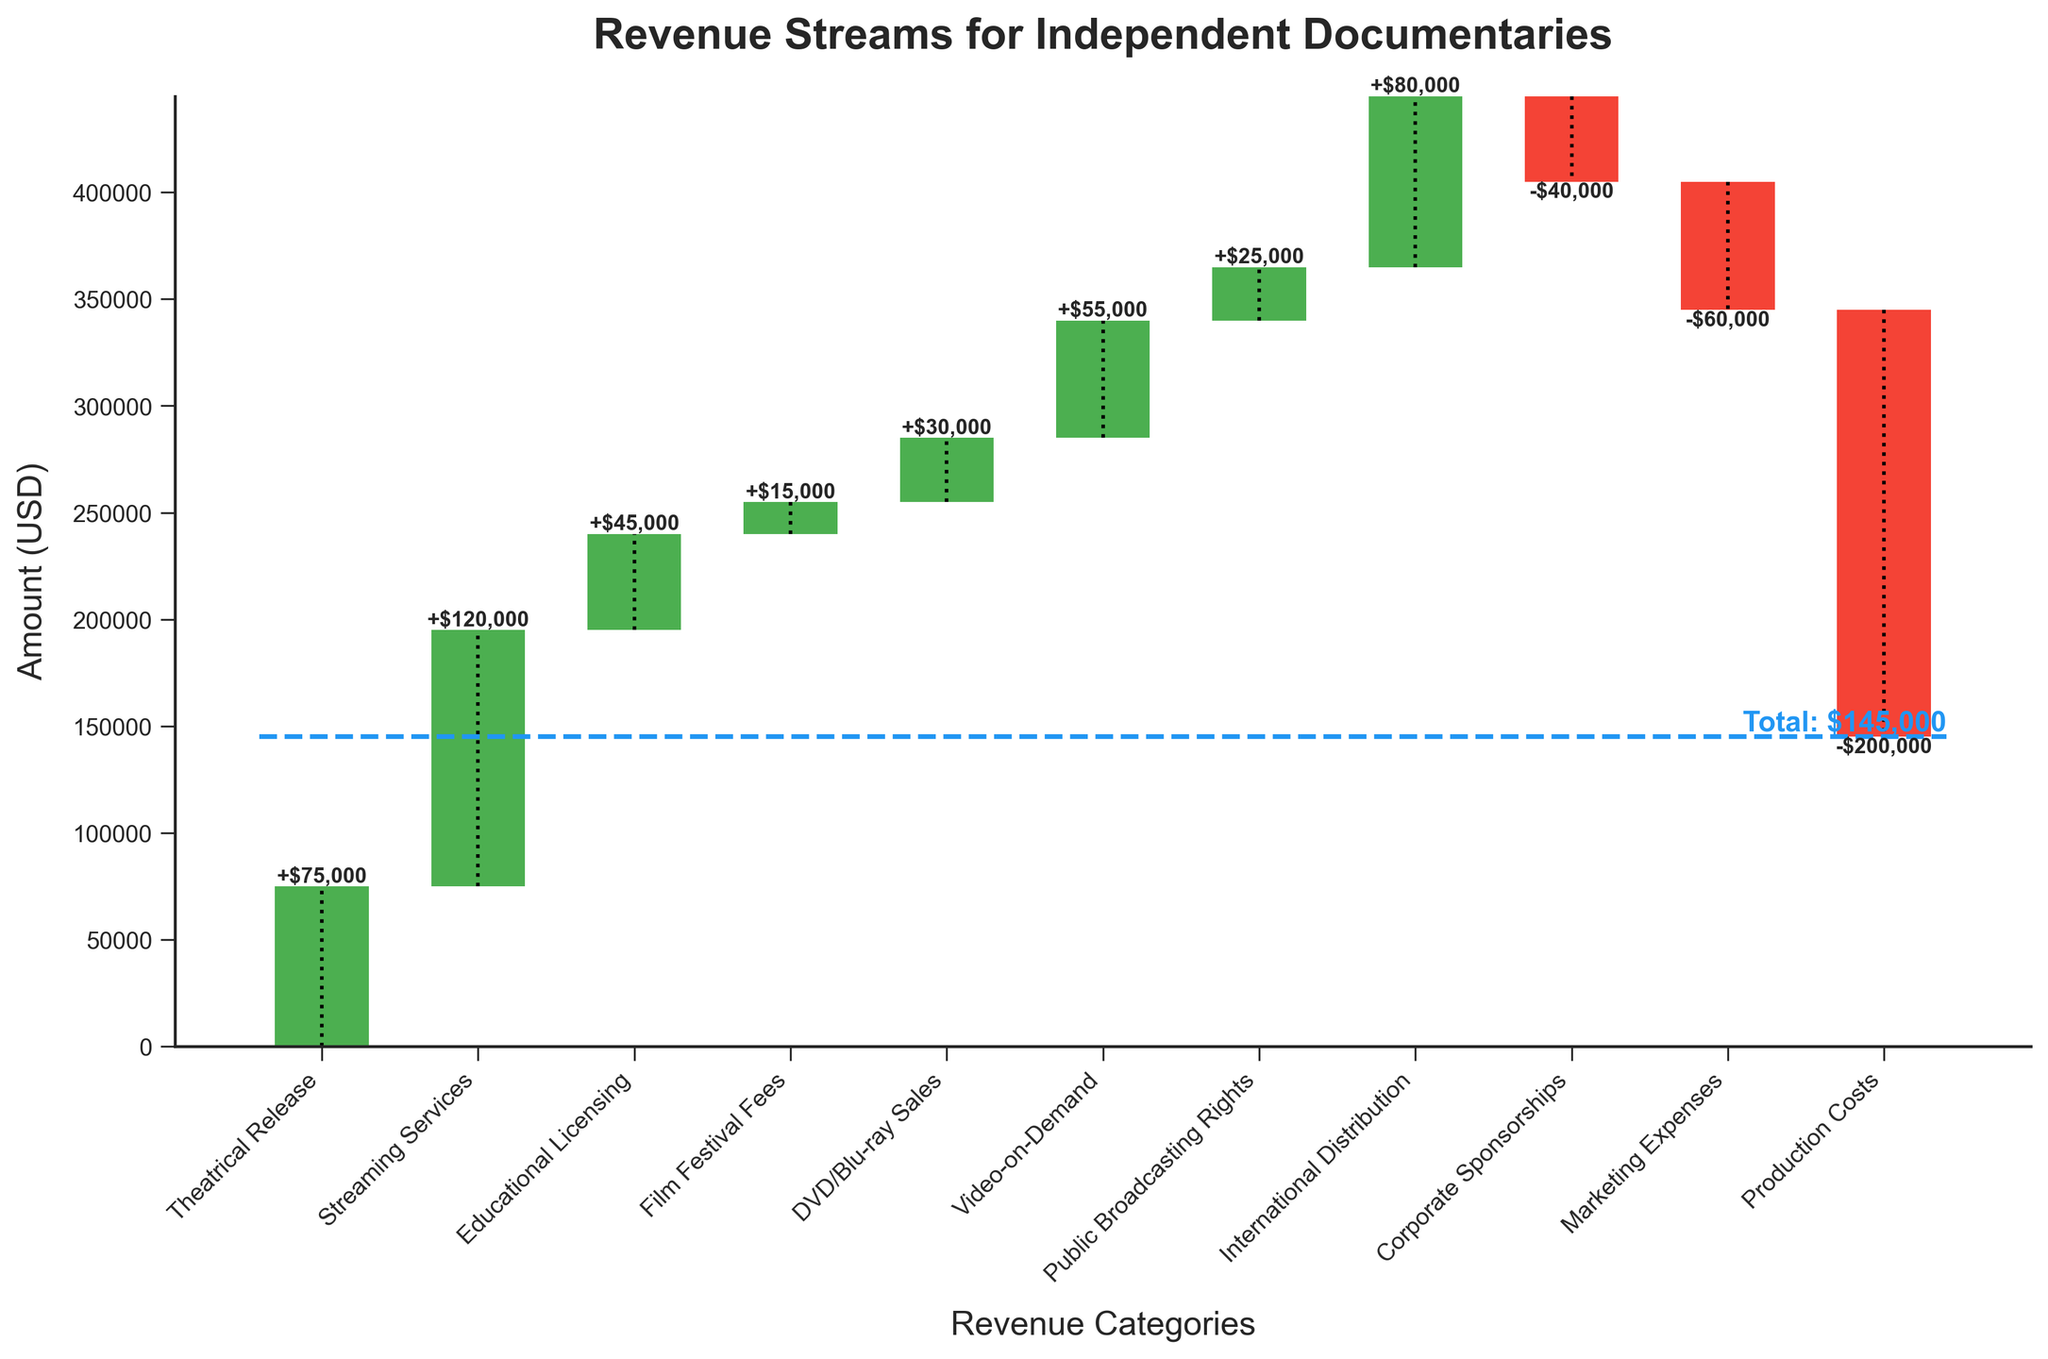What is the title of the chart? The title of the chart can be found at the top and it reads 'Revenue Streams for Independent Documentaries'.
Answer: Revenue Streams for Independent Documentaries Which revenue category has the highest value? By looking at the height of the bars, 'Streaming Services' has the highest value of $120,000.
Answer: Streaming Services What is the total value of positive revenue streams? Summing all positive values: Theatrical Release ($75,000) + Streaming Services ($120,000) + Educational Licensing ($45,000) + Film Festival Fees ($15,000) + DVD/Blu-ray Sales ($30,000) + Video-on-Demand ($55,000) + Public Broadcasting Rights ($25,000) + International Distribution ($80,000) = $445,000.
Answer: $445,000 Which categories are associated with negative values? The bars in red represent negative values, which are 'Corporate Sponsorships' (-$40,000), 'Marketing Expenses' (-$60,000), and 'Production Costs' (-$200,000).
Answer: Corporate Sponsorships, Marketing Expenses, Production Costs How does the total revenue compare to the sum of positive revenue streams? The total revenue is $145,000 while the sum of positive revenue streams is $445,000. The difference is: $445,000 - $145,000 = $300,000. This means the negative values account for $300,000.
Answer: The total revenue is $300,000 less than the sum of positive revenue streams What is the impact of production costs on the cumulative revenue? Production Costs is a negative value of -$200,000, significantly reducing the cumulative revenue as it is the largest negative contributor.
Answer: Reduces cumulative revenue by $200,000 Which category has the smallest positive value? By looking at the height of the smallest green bar, 'Film Festival Fees' has the smallest positive value of $15,000.
Answer: Film Festival Fees What is the cumulative revenue before the impact of production costs? Summing up values before Production Costs: $75,000 (Theatrical Release) + $120,000 (Streaming Services) + $45,000 (Educational Licensing) + $15,000 (Film Festival Fees) + $30,000 (DVD/Blu-ray Sales) + $55,000 (Video-on-Demand) + $25,000 (Public Broadcasting Rights) + $80,000 (International Distribution) - $40,000 (Corporate Sponsorships) - $60,000 (Marketing Expenses) = $345,000.
Answer: $345,000 What contributes more to revenue, Theatrical Release or International Distribution? Comparing the heights of the bars, 'International Distribution' contributes more ($80,000) than 'Theatrical Release' ($75,000).
Answer: International Distribution Is the total revenue higher or lower than $200,000? By looking at the final cumulative value line and label, the total revenue is shown to be $145,000, which is lower than $200,000.
Answer: Lower 